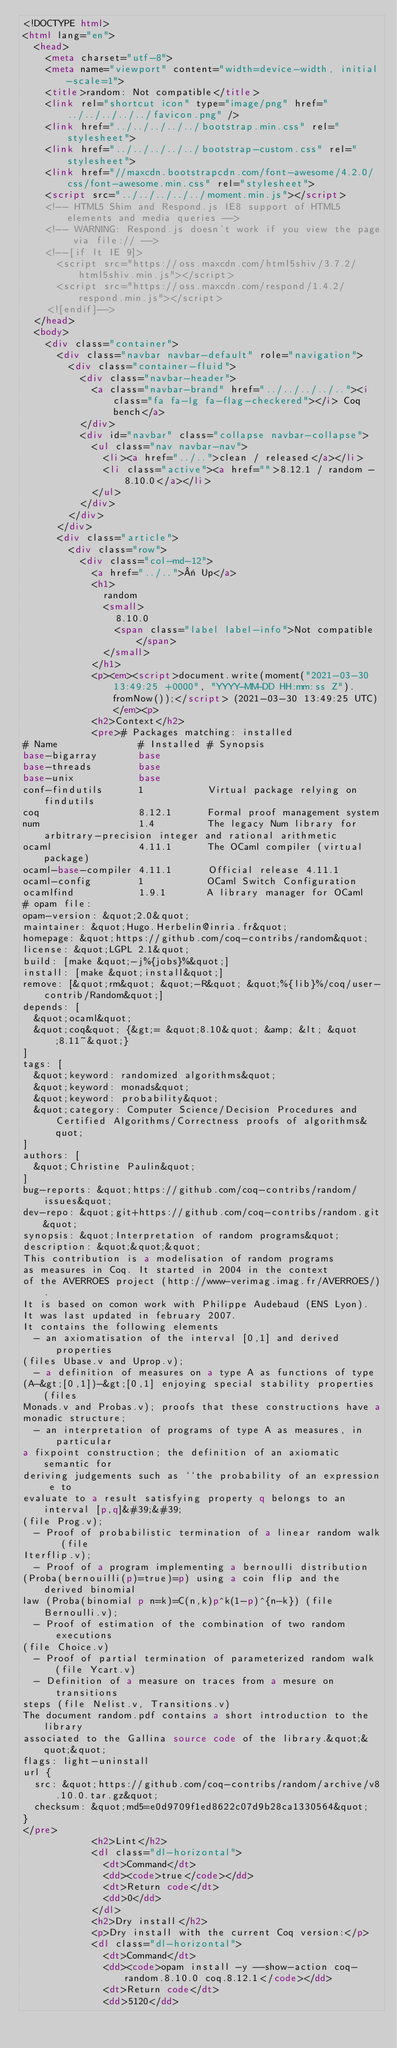<code> <loc_0><loc_0><loc_500><loc_500><_HTML_><!DOCTYPE html>
<html lang="en">
  <head>
    <meta charset="utf-8">
    <meta name="viewport" content="width=device-width, initial-scale=1">
    <title>random: Not compatible</title>
    <link rel="shortcut icon" type="image/png" href="../../../../../favicon.png" />
    <link href="../../../../../bootstrap.min.css" rel="stylesheet">
    <link href="../../../../../bootstrap-custom.css" rel="stylesheet">
    <link href="//maxcdn.bootstrapcdn.com/font-awesome/4.2.0/css/font-awesome.min.css" rel="stylesheet">
    <script src="../../../../../moment.min.js"></script>
    <!-- HTML5 Shim and Respond.js IE8 support of HTML5 elements and media queries -->
    <!-- WARNING: Respond.js doesn't work if you view the page via file:// -->
    <!--[if lt IE 9]>
      <script src="https://oss.maxcdn.com/html5shiv/3.7.2/html5shiv.min.js"></script>
      <script src="https://oss.maxcdn.com/respond/1.4.2/respond.min.js"></script>
    <![endif]-->
  </head>
  <body>
    <div class="container">
      <div class="navbar navbar-default" role="navigation">
        <div class="container-fluid">
          <div class="navbar-header">
            <a class="navbar-brand" href="../../../../.."><i class="fa fa-lg fa-flag-checkered"></i> Coq bench</a>
          </div>
          <div id="navbar" class="collapse navbar-collapse">
            <ul class="nav navbar-nav">
              <li><a href="../..">clean / released</a></li>
              <li class="active"><a href="">8.12.1 / random - 8.10.0</a></li>
            </ul>
          </div>
        </div>
      </div>
      <div class="article">
        <div class="row">
          <div class="col-md-12">
            <a href="../..">« Up</a>
            <h1>
              random
              <small>
                8.10.0
                <span class="label label-info">Not compatible</span>
              </small>
            </h1>
            <p><em><script>document.write(moment("2021-03-30 13:49:25 +0000", "YYYY-MM-DD HH:mm:ss Z").fromNow());</script> (2021-03-30 13:49:25 UTC)</em><p>
            <h2>Context</h2>
            <pre># Packages matching: installed
# Name              # Installed # Synopsis
base-bigarray       base
base-threads        base
base-unix           base
conf-findutils      1           Virtual package relying on findutils
coq                 8.12.1      Formal proof management system
num                 1.4         The legacy Num library for arbitrary-precision integer and rational arithmetic
ocaml               4.11.1      The OCaml compiler (virtual package)
ocaml-base-compiler 4.11.1      Official release 4.11.1
ocaml-config        1           OCaml Switch Configuration
ocamlfind           1.9.1       A library manager for OCaml
# opam file:
opam-version: &quot;2.0&quot;
maintainer: &quot;Hugo.Herbelin@inria.fr&quot;
homepage: &quot;https://github.com/coq-contribs/random&quot;
license: &quot;LGPL 2.1&quot;
build: [make &quot;-j%{jobs}%&quot;]
install: [make &quot;install&quot;]
remove: [&quot;rm&quot; &quot;-R&quot; &quot;%{lib}%/coq/user-contrib/Random&quot;]
depends: [
  &quot;ocaml&quot;
  &quot;coq&quot; {&gt;= &quot;8.10&quot; &amp; &lt; &quot;8.11~&quot;}
]
tags: [
  &quot;keyword: randomized algorithms&quot;
  &quot;keyword: monads&quot;
  &quot;keyword: probability&quot;
  &quot;category: Computer Science/Decision Procedures and Certified Algorithms/Correctness proofs of algorithms&quot;
]
authors: [
  &quot;Christine Paulin&quot;
]
bug-reports: &quot;https://github.com/coq-contribs/random/issues&quot;
dev-repo: &quot;git+https://github.com/coq-contribs/random.git&quot;
synopsis: &quot;Interpretation of random programs&quot;
description: &quot;&quot;&quot;
This contribution is a modelisation of random programs
as measures in Coq. It started in 2004 in the context
of the AVERROES project (http://www-verimag.imag.fr/AVERROES/).
It is based on comon work with Philippe Audebaud (ENS Lyon).
It was last updated in february 2007.
It contains the following elements
  - an axiomatisation of the interval [0,1] and derived properties
(files Ubase.v and Uprop.v);
  - a definition of measures on a type A as functions of type
(A-&gt;[0,1])-&gt;[0,1] enjoying special stability properties (files
Monads.v and Probas.v); proofs that these constructions have a
monadic structure;
  - an interpretation of programs of type A as measures, in particular
a fixpoint construction; the definition of an axiomatic semantic for
deriving judgements such as ``the probability of an expression e to
evaluate to a result satisfying property q belongs to an interval [p,q]&#39;&#39;
(file Prog.v);
  - Proof of probabilistic termination of a linear random walk (file
Iterflip.v);
  - Proof of a program implementing a bernoulli distribution
(Proba(bernouilli(p)=true)=p) using a coin flip and the derived binomial
law (Proba(binomial p n=k)=C(n,k)p^k(1-p)^{n-k}) (file Bernoulli.v);
  - Proof of estimation of the combination of two random executions
(file Choice.v)
  - Proof of partial termination of parameterized random walk (file Ycart.v)
  - Definition of a measure on traces from a mesure on transitions
steps (file Nelist.v, Transitions.v)
The document random.pdf contains a short introduction to the library
associated to the Gallina source code of the library.&quot;&quot;&quot;
flags: light-uninstall
url {
  src: &quot;https://github.com/coq-contribs/random/archive/v8.10.0.tar.gz&quot;
  checksum: &quot;md5=e0d9709f1ed8622c07d9b28ca1330564&quot;
}
</pre>
            <h2>Lint</h2>
            <dl class="dl-horizontal">
              <dt>Command</dt>
              <dd><code>true</code></dd>
              <dt>Return code</dt>
              <dd>0</dd>
            </dl>
            <h2>Dry install</h2>
            <p>Dry install with the current Coq version:</p>
            <dl class="dl-horizontal">
              <dt>Command</dt>
              <dd><code>opam install -y --show-action coq-random.8.10.0 coq.8.12.1</code></dd>
              <dt>Return code</dt>
              <dd>5120</dd></code> 